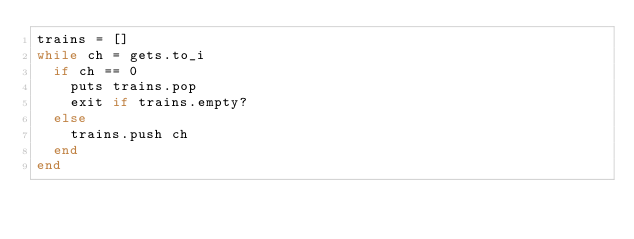Convert code to text. <code><loc_0><loc_0><loc_500><loc_500><_Ruby_>trains = []
while ch = gets.to_i
  if ch == 0
  	puts trains.pop
  	exit if trains.empty?
  else
  	trains.push ch
  end
end</code> 